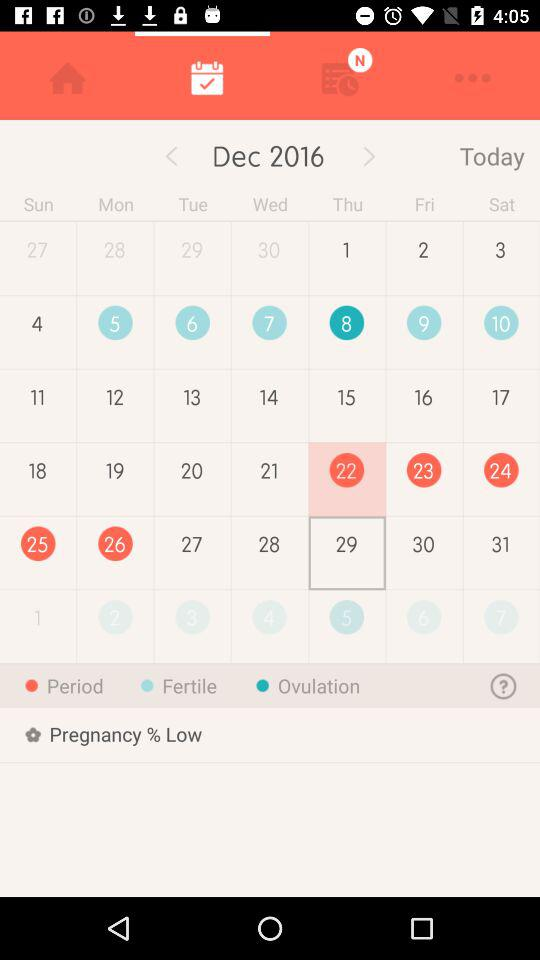What is the percentage of pregnancy?
Answer the question using a single word or phrase. Low 